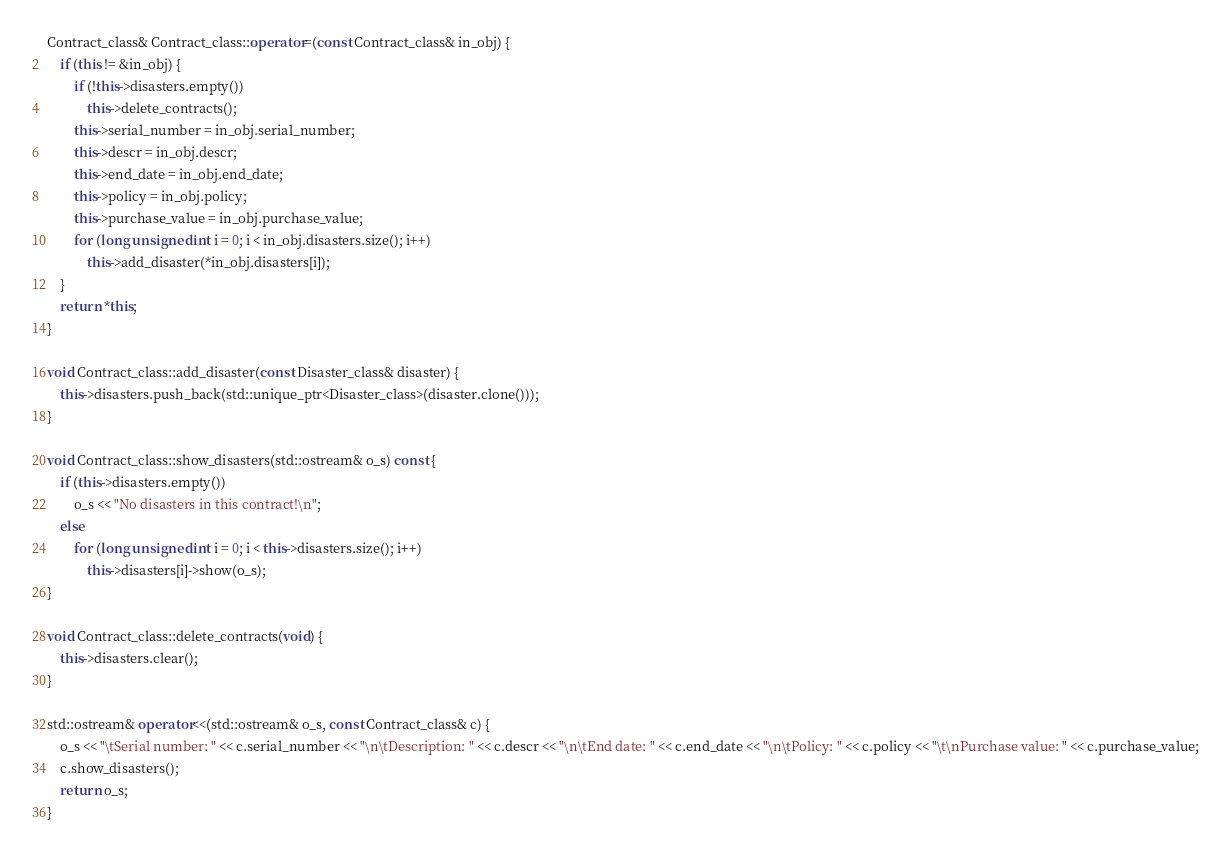Convert code to text. <code><loc_0><loc_0><loc_500><loc_500><_C++_>
Contract_class& Contract_class::operator=(const Contract_class& in_obj) {
    if (this != &in_obj) {
        if (!this->disasters.empty())
            this->delete_contracts();
        this->serial_number = in_obj.serial_number;
        this->descr = in_obj.descr;
        this->end_date = in_obj.end_date;
        this->policy = in_obj.policy;
        this->purchase_value = in_obj.purchase_value;
        for (long unsigned int i = 0; i < in_obj.disasters.size(); i++)
            this->add_disaster(*in_obj.disasters[i]);
    }
    return *this;
}

void Contract_class::add_disaster(const Disaster_class& disaster) {
    this->disasters.push_back(std::unique_ptr<Disaster_class>(disaster.clone()));
}

void Contract_class::show_disasters(std::ostream& o_s) const {
    if (this->disasters.empty())
        o_s << "No disasters in this contract!\n";
    else
        for (long unsigned int i = 0; i < this->disasters.size(); i++)
            this->disasters[i]->show(o_s);
}

void Contract_class::delete_contracts(void) {
    this->disasters.clear();
}

std::ostream& operator<<(std::ostream& o_s, const Contract_class& c) {
    o_s << "\tSerial number: " << c.serial_number << "\n\tDescription: " << c.descr << "\n\tEnd date: " << c.end_date << "\n\tPolicy: " << c.policy << "\t\nPurchase value: " << c.purchase_value;
    c.show_disasters();
    return o_s;
}</code> 